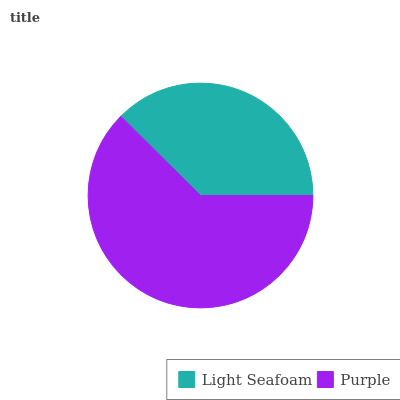Is Light Seafoam the minimum?
Answer yes or no. Yes. Is Purple the maximum?
Answer yes or no. Yes. Is Purple the minimum?
Answer yes or no. No. Is Purple greater than Light Seafoam?
Answer yes or no. Yes. Is Light Seafoam less than Purple?
Answer yes or no. Yes. Is Light Seafoam greater than Purple?
Answer yes or no. No. Is Purple less than Light Seafoam?
Answer yes or no. No. Is Purple the high median?
Answer yes or no. Yes. Is Light Seafoam the low median?
Answer yes or no. Yes. Is Light Seafoam the high median?
Answer yes or no. No. Is Purple the low median?
Answer yes or no. No. 